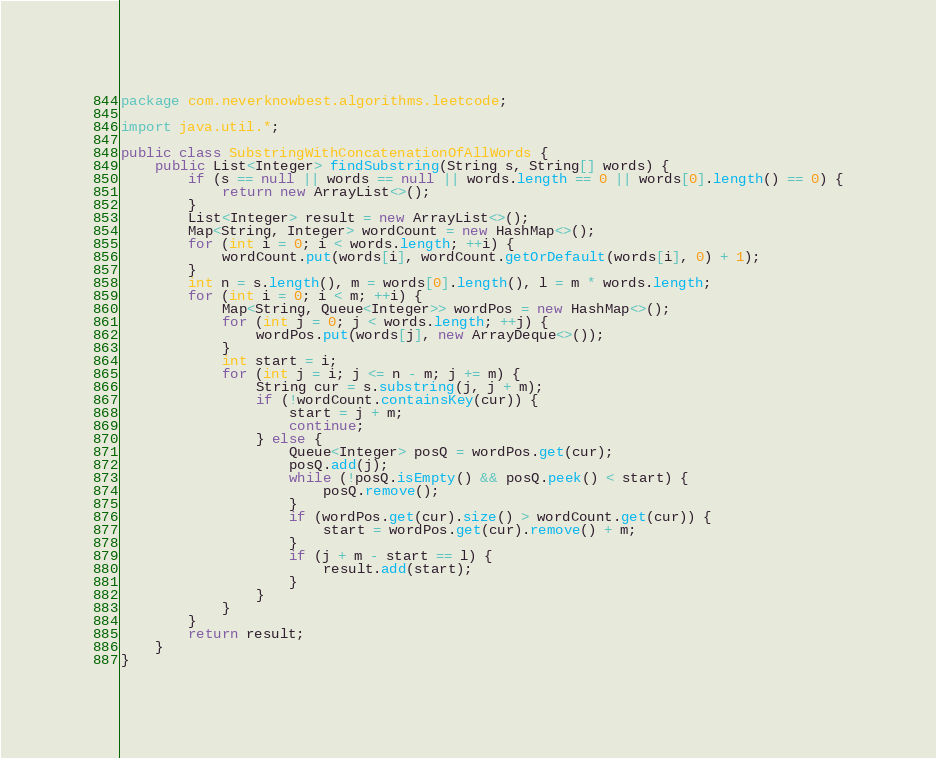Convert code to text. <code><loc_0><loc_0><loc_500><loc_500><_Java_>package com.neverknowbest.algorithms.leetcode;

import java.util.*;

public class SubstringWithConcatenationOfAllWords {
    public List<Integer> findSubstring(String s, String[] words) {
        if (s == null || words == null || words.length == 0 || words[0].length() == 0) {
            return new ArrayList<>();
        }
        List<Integer> result = new ArrayList<>();
        Map<String, Integer> wordCount = new HashMap<>();
        for (int i = 0; i < words.length; ++i) {
            wordCount.put(words[i], wordCount.getOrDefault(words[i], 0) + 1);
        }
        int n = s.length(), m = words[0].length(), l = m * words.length;
        for (int i = 0; i < m; ++i) {
            Map<String, Queue<Integer>> wordPos = new HashMap<>();
            for (int j = 0; j < words.length; ++j) {
                wordPos.put(words[j], new ArrayDeque<>());
            }
            int start = i;
            for (int j = i; j <= n - m; j += m) {
                String cur = s.substring(j, j + m);
                if (!wordCount.containsKey(cur)) {
                    start = j + m;
                    continue;
                } else {
                    Queue<Integer> posQ = wordPos.get(cur);
                    posQ.add(j);
                    while (!posQ.isEmpty() && posQ.peek() < start) {
                        posQ.remove();
                    }
                    if (wordPos.get(cur).size() > wordCount.get(cur)) {
                        start = wordPos.get(cur).remove() + m;
                    }
                    if (j + m - start == l) {
                        result.add(start);
                    }
                }
            }
        }
        return result;
    }
}
</code> 